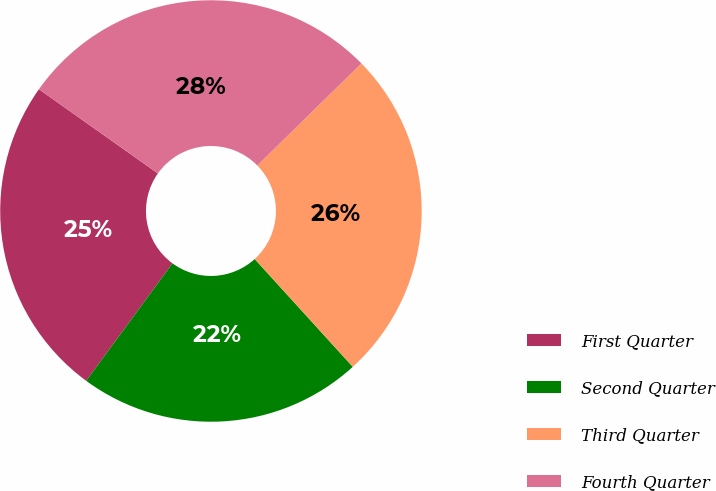Convert chart to OTSL. <chart><loc_0><loc_0><loc_500><loc_500><pie_chart><fcel>First Quarter<fcel>Second Quarter<fcel>Third Quarter<fcel>Fourth Quarter<nl><fcel>24.72%<fcel>21.83%<fcel>25.59%<fcel>27.85%<nl></chart> 